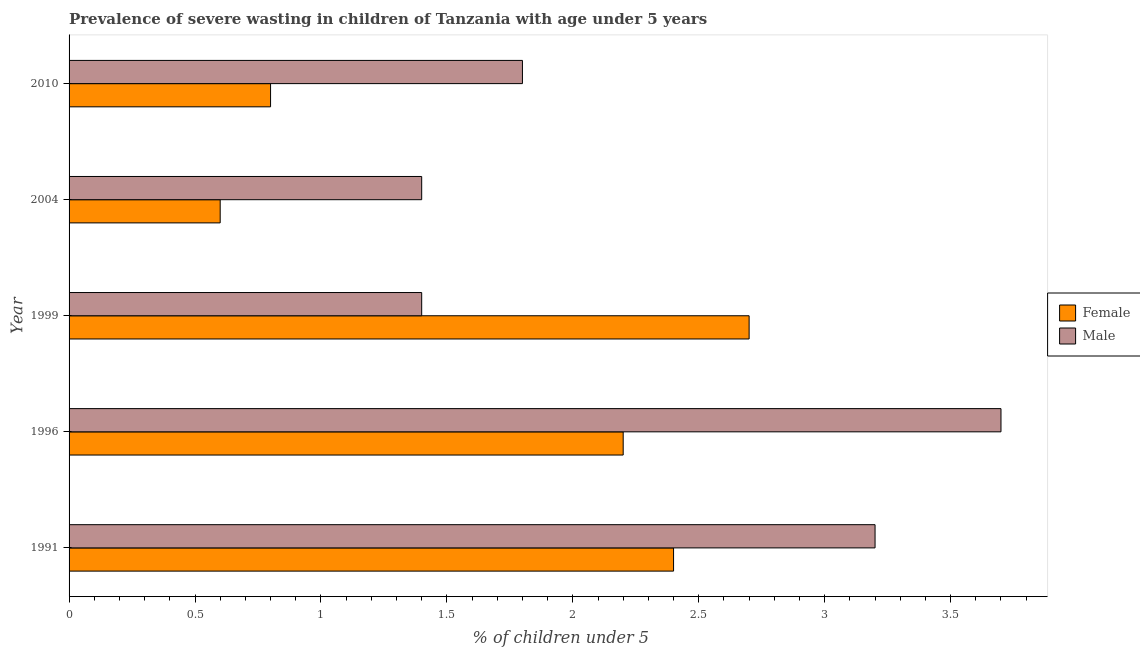How many different coloured bars are there?
Ensure brevity in your answer.  2. How many groups of bars are there?
Keep it short and to the point. 5. What is the label of the 3rd group of bars from the top?
Give a very brief answer. 1999. What is the percentage of undernourished male children in 2004?
Provide a short and direct response. 1.4. Across all years, what is the maximum percentage of undernourished male children?
Provide a succinct answer. 3.7. Across all years, what is the minimum percentage of undernourished female children?
Offer a terse response. 0.6. In which year was the percentage of undernourished female children minimum?
Your answer should be very brief. 2004. What is the total percentage of undernourished male children in the graph?
Ensure brevity in your answer.  11.5. What is the difference between the percentage of undernourished female children in 1996 and that in 1999?
Ensure brevity in your answer.  -0.5. What is the difference between the percentage of undernourished male children in 2010 and the percentage of undernourished female children in 1991?
Your response must be concise. -0.6. What is the average percentage of undernourished male children per year?
Offer a very short reply. 2.3. In the year 1996, what is the difference between the percentage of undernourished male children and percentage of undernourished female children?
Keep it short and to the point. 1.5. In how many years, is the percentage of undernourished female children greater than 3.5 %?
Your response must be concise. 0. What is the ratio of the percentage of undernourished male children in 1999 to that in 2004?
Give a very brief answer. 1. What is the difference between the highest and the second highest percentage of undernourished female children?
Give a very brief answer. 0.3. What is the difference between the highest and the lowest percentage of undernourished male children?
Offer a very short reply. 2.3. What does the 1st bar from the bottom in 2010 represents?
Your answer should be very brief. Female. How many bars are there?
Provide a short and direct response. 10. Are all the bars in the graph horizontal?
Provide a succinct answer. Yes. How many years are there in the graph?
Ensure brevity in your answer.  5. How are the legend labels stacked?
Your answer should be compact. Vertical. What is the title of the graph?
Your answer should be very brief. Prevalence of severe wasting in children of Tanzania with age under 5 years. What is the label or title of the X-axis?
Offer a very short reply.  % of children under 5. What is the label or title of the Y-axis?
Provide a succinct answer. Year. What is the  % of children under 5 of Female in 1991?
Your answer should be very brief. 2.4. What is the  % of children under 5 in Male in 1991?
Your response must be concise. 3.2. What is the  % of children under 5 in Female in 1996?
Your response must be concise. 2.2. What is the  % of children under 5 in Male in 1996?
Give a very brief answer. 3.7. What is the  % of children under 5 of Female in 1999?
Your answer should be very brief. 2.7. What is the  % of children under 5 in Male in 1999?
Your answer should be compact. 1.4. What is the  % of children under 5 of Female in 2004?
Offer a very short reply. 0.6. What is the  % of children under 5 of Male in 2004?
Give a very brief answer. 1.4. What is the  % of children under 5 in Female in 2010?
Provide a short and direct response. 0.8. What is the  % of children under 5 of Male in 2010?
Your response must be concise. 1.8. Across all years, what is the maximum  % of children under 5 in Female?
Make the answer very short. 2.7. Across all years, what is the maximum  % of children under 5 in Male?
Your response must be concise. 3.7. Across all years, what is the minimum  % of children under 5 in Female?
Ensure brevity in your answer.  0.6. Across all years, what is the minimum  % of children under 5 in Male?
Keep it short and to the point. 1.4. What is the total  % of children under 5 of Male in the graph?
Your answer should be very brief. 11.5. What is the difference between the  % of children under 5 of Male in 1991 and that in 1996?
Offer a very short reply. -0.5. What is the difference between the  % of children under 5 of Female in 1991 and that in 1999?
Your answer should be very brief. -0.3. What is the difference between the  % of children under 5 in Female in 1991 and that in 2004?
Make the answer very short. 1.8. What is the difference between the  % of children under 5 in Male in 1991 and that in 2004?
Provide a short and direct response. 1.8. What is the difference between the  % of children under 5 of Female in 1996 and that in 1999?
Offer a terse response. -0.5. What is the difference between the  % of children under 5 of Male in 1996 and that in 1999?
Your answer should be compact. 2.3. What is the difference between the  % of children under 5 in Female in 1996 and that in 2004?
Offer a very short reply. 1.6. What is the difference between the  % of children under 5 in Female in 1996 and that in 2010?
Offer a very short reply. 1.4. What is the difference between the  % of children under 5 in Male in 1996 and that in 2010?
Your answer should be very brief. 1.9. What is the difference between the  % of children under 5 in Female in 1999 and that in 2004?
Your answer should be very brief. 2.1. What is the difference between the  % of children under 5 of Male in 1999 and that in 2004?
Keep it short and to the point. 0. What is the difference between the  % of children under 5 in Female in 1999 and that in 2010?
Give a very brief answer. 1.9. What is the difference between the  % of children under 5 in Male in 1999 and that in 2010?
Keep it short and to the point. -0.4. What is the difference between the  % of children under 5 in Male in 2004 and that in 2010?
Your response must be concise. -0.4. What is the difference between the  % of children under 5 in Female in 1991 and the  % of children under 5 in Male in 2004?
Ensure brevity in your answer.  1. What is the difference between the  % of children under 5 in Female in 1991 and the  % of children under 5 in Male in 2010?
Provide a short and direct response. 0.6. What is the difference between the  % of children under 5 of Female in 2004 and the  % of children under 5 of Male in 2010?
Provide a succinct answer. -1.2. What is the average  % of children under 5 in Female per year?
Your answer should be very brief. 1.74. In the year 1996, what is the difference between the  % of children under 5 in Female and  % of children under 5 in Male?
Offer a very short reply. -1.5. In the year 1999, what is the difference between the  % of children under 5 of Female and  % of children under 5 of Male?
Provide a succinct answer. 1.3. In the year 2010, what is the difference between the  % of children under 5 in Female and  % of children under 5 in Male?
Your response must be concise. -1. What is the ratio of the  % of children under 5 in Female in 1991 to that in 1996?
Keep it short and to the point. 1.09. What is the ratio of the  % of children under 5 in Male in 1991 to that in 1996?
Provide a succinct answer. 0.86. What is the ratio of the  % of children under 5 of Male in 1991 to that in 1999?
Keep it short and to the point. 2.29. What is the ratio of the  % of children under 5 of Male in 1991 to that in 2004?
Your answer should be very brief. 2.29. What is the ratio of the  % of children under 5 of Male in 1991 to that in 2010?
Offer a very short reply. 1.78. What is the ratio of the  % of children under 5 of Female in 1996 to that in 1999?
Ensure brevity in your answer.  0.81. What is the ratio of the  % of children under 5 of Male in 1996 to that in 1999?
Make the answer very short. 2.64. What is the ratio of the  % of children under 5 of Female in 1996 to that in 2004?
Keep it short and to the point. 3.67. What is the ratio of the  % of children under 5 in Male in 1996 to that in 2004?
Offer a very short reply. 2.64. What is the ratio of the  % of children under 5 in Female in 1996 to that in 2010?
Ensure brevity in your answer.  2.75. What is the ratio of the  % of children under 5 of Male in 1996 to that in 2010?
Make the answer very short. 2.06. What is the ratio of the  % of children under 5 of Female in 1999 to that in 2004?
Make the answer very short. 4.5. What is the ratio of the  % of children under 5 of Female in 1999 to that in 2010?
Offer a terse response. 3.38. What is the difference between the highest and the second highest  % of children under 5 in Male?
Give a very brief answer. 0.5. What is the difference between the highest and the lowest  % of children under 5 in Male?
Offer a very short reply. 2.3. 